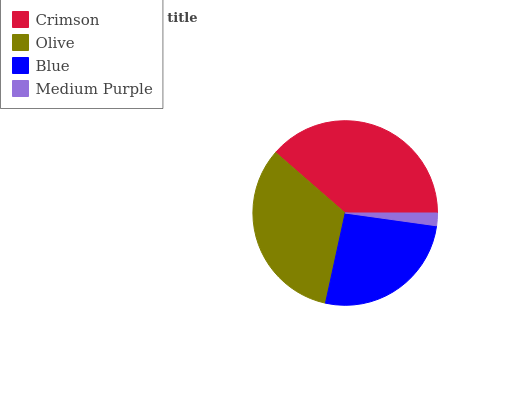Is Medium Purple the minimum?
Answer yes or no. Yes. Is Crimson the maximum?
Answer yes or no. Yes. Is Olive the minimum?
Answer yes or no. No. Is Olive the maximum?
Answer yes or no. No. Is Crimson greater than Olive?
Answer yes or no. Yes. Is Olive less than Crimson?
Answer yes or no. Yes. Is Olive greater than Crimson?
Answer yes or no. No. Is Crimson less than Olive?
Answer yes or no. No. Is Olive the high median?
Answer yes or no. Yes. Is Blue the low median?
Answer yes or no. Yes. Is Blue the high median?
Answer yes or no. No. Is Medium Purple the low median?
Answer yes or no. No. 